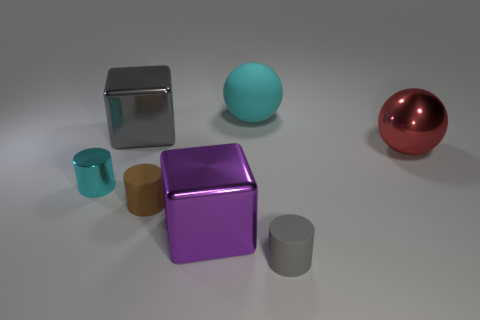Add 3 big gray blocks. How many objects exist? 10 Subtract all cubes. How many objects are left? 5 Add 2 brown things. How many brown things exist? 3 Subtract 1 purple cubes. How many objects are left? 6 Subtract all big metallic balls. Subtract all small things. How many objects are left? 3 Add 4 small brown things. How many small brown things are left? 5 